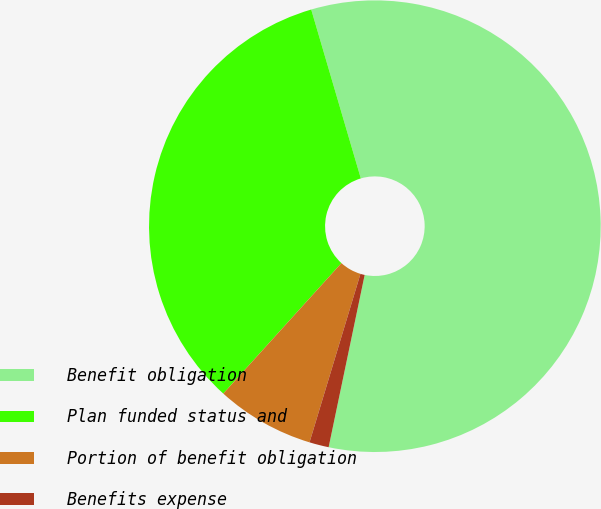Convert chart to OTSL. <chart><loc_0><loc_0><loc_500><loc_500><pie_chart><fcel>Benefit obligation<fcel>Plan funded status and<fcel>Portion of benefit obligation<fcel>Benefits expense<nl><fcel>57.83%<fcel>33.74%<fcel>7.04%<fcel>1.39%<nl></chart> 